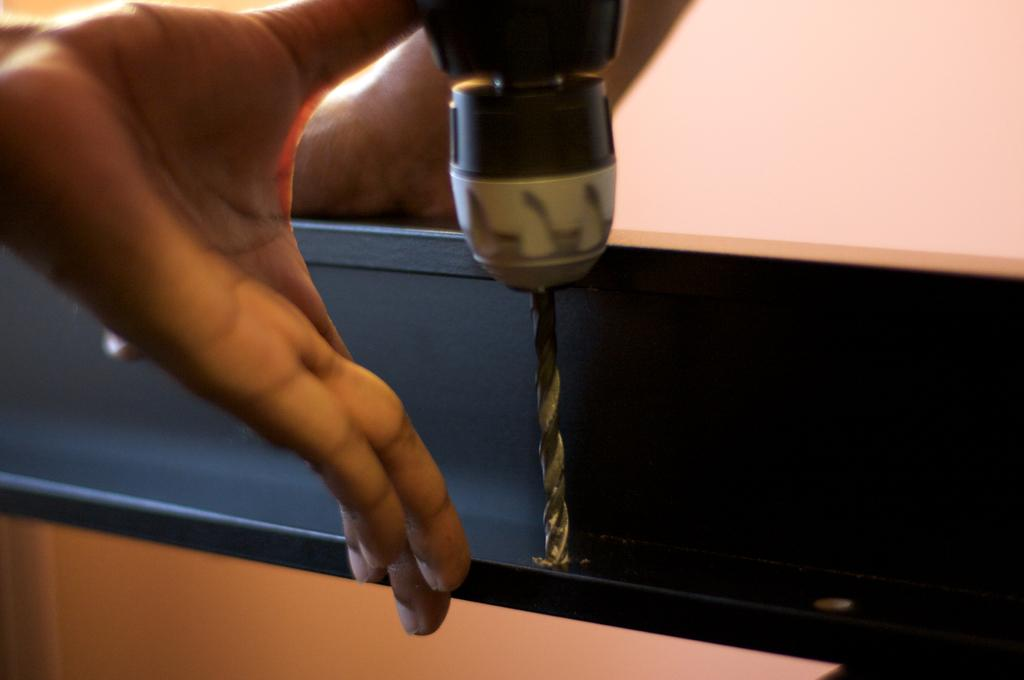What can be seen in the image related to a person's body part? There is a hand in the image. What type of tool is present in the image? There is a drilling machine in the image. What is the drilling machine doing in the image? The drilling machine is dripping something on an object. What type of veil is being used to smother the fire in the image? There is no fire or veil present in the image; it features a hand and a drilling machine. What is the drilling machine smashing in the image? The drilling machine is not shown smashing anything in the image; it is dripping something on an object. 